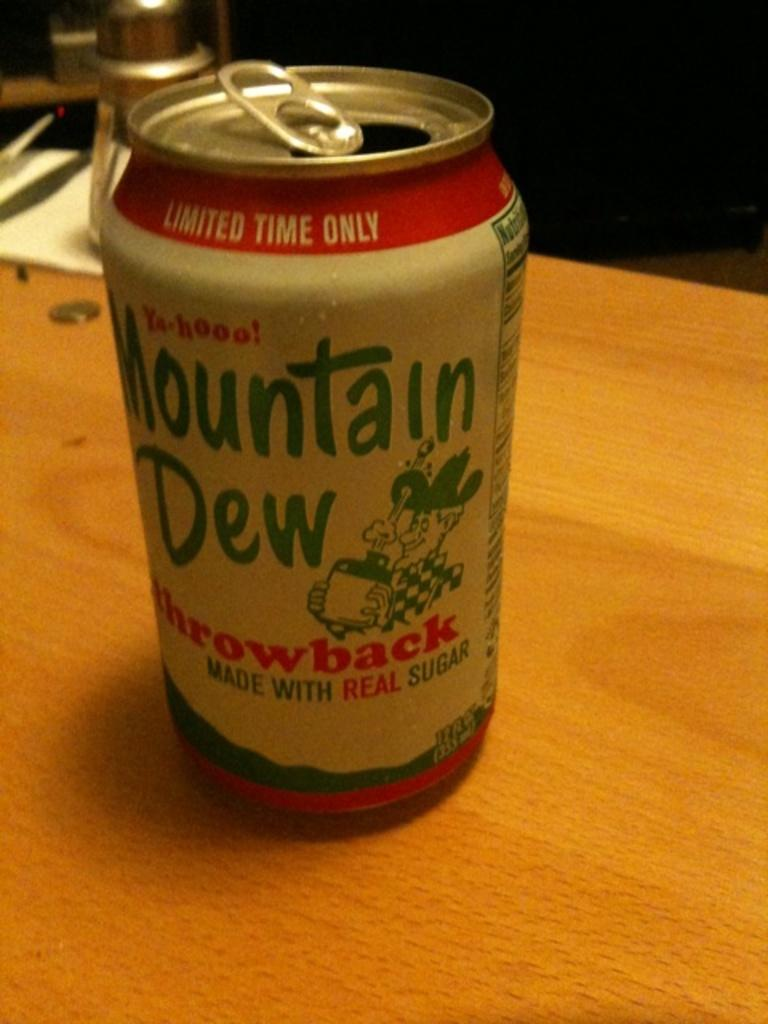<image>
Relay a brief, clear account of the picture shown. a can that says mountain dew on it 